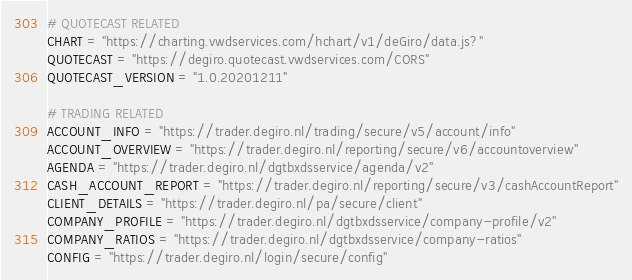<code> <loc_0><loc_0><loc_500><loc_500><_Python_># QUOTECAST RELATED
CHART = "https://charting.vwdservices.com/hchart/v1/deGiro/data.js?"
QUOTECAST = "https://degiro.quotecast.vwdservices.com/CORS"
QUOTECAST_VERSION = "1.0.20201211"

# TRADING RELATED
ACCOUNT_INFO = "https://trader.degiro.nl/trading/secure/v5/account/info"
ACCOUNT_OVERVIEW = "https://trader.degiro.nl/reporting/secure/v6/accountoverview"
AGENDA = "https://trader.degiro.nl/dgtbxdsservice/agenda/v2"
CASH_ACCOUNT_REPORT = "https://trader.degiro.nl/reporting/secure/v3/cashAccountReport"
CLIENT_DETAILS = "https://trader.degiro.nl/pa/secure/client"
COMPANY_PROFILE = "https://trader.degiro.nl/dgtbxdsservice/company-profile/v2"
COMPANY_RATIOS = "https://trader.degiro.nl/dgtbxdsservice/company-ratios"
CONFIG = "https://trader.degiro.nl/login/secure/config"</code> 